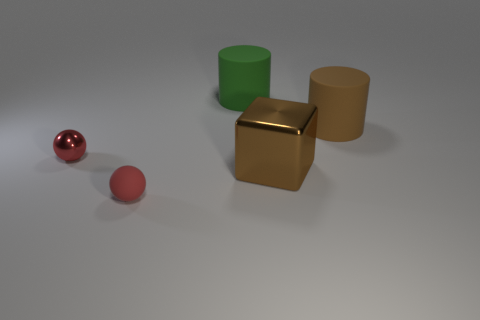Add 4 big matte cylinders. How many objects exist? 9 Subtract all green cylinders. How many cylinders are left? 1 Subtract all blocks. How many objects are left? 4 Subtract 1 cylinders. How many cylinders are left? 1 Add 2 blue metal balls. How many blue metal balls exist? 2 Subtract 0 blue spheres. How many objects are left? 5 Subtract all gray cylinders. Subtract all cyan balls. How many cylinders are left? 2 Subtract all purple metal cylinders. Subtract all large brown cylinders. How many objects are left? 4 Add 4 big objects. How many big objects are left? 7 